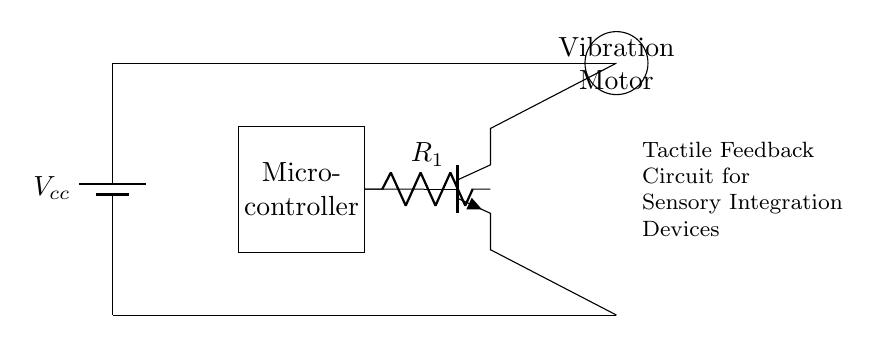What is the power supply component in this circuit? The power supply component is labeled as Vcc, a battery that provides the necessary voltage for the circuit to operate.
Answer: battery What connects the microcontroller to the transistor in this circuit? A resistor labeled R1 connects the microcontroller to the base of the transistor, controlling its switching.
Answer: R1 What is the function of the vibration motor in this circuit? The vibration motor serves as the output device providing tactile feedback when activated by the microcontroller through the transistor.
Answer: tactile feedback How many main components are present in this circuit? The circuit includes four main components: a power supply, a microcontroller, a transistor, and a vibration motor.
Answer: four What is the role of the transistor in this circuit? The transistor acts as a switch that is controlled by the microcontroller, allowing it to connect the vibration motor to the power supply when needed.
Answer: switch Which side of the circuit has the lower potential? The lower potential side is connected to the emitter of the transistor, designated as the ground reference, where current flows out.
Answer: ground 